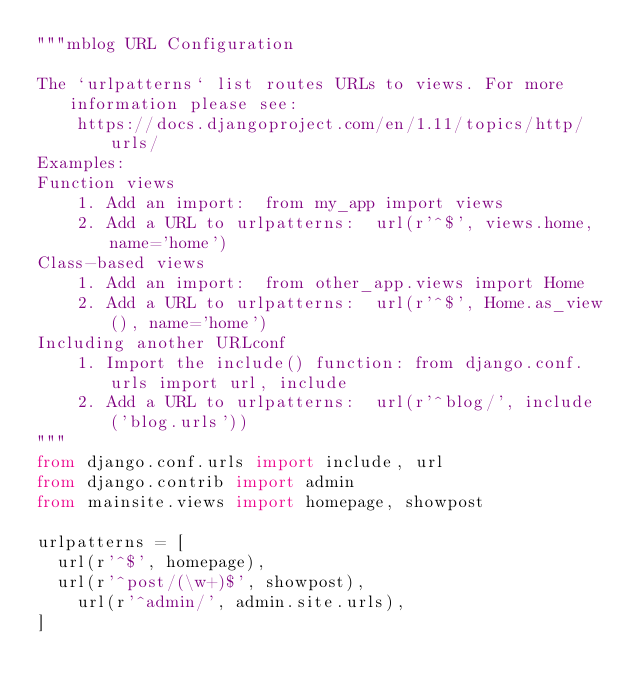<code> <loc_0><loc_0><loc_500><loc_500><_Python_>"""mblog URL Configuration

The `urlpatterns` list routes URLs to views. For more information please see:
    https://docs.djangoproject.com/en/1.11/topics/http/urls/
Examples:
Function views
    1. Add an import:  from my_app import views
    2. Add a URL to urlpatterns:  url(r'^$', views.home, name='home')
Class-based views
    1. Add an import:  from other_app.views import Home
    2. Add a URL to urlpatterns:  url(r'^$', Home.as_view(), name='home')
Including another URLconf
    1. Import the include() function: from django.conf.urls import url, include
    2. Add a URL to urlpatterns:  url(r'^blog/', include('blog.urls'))
"""
from django.conf.urls import include, url
from django.contrib import admin
from mainsite.views import homepage, showpost

urlpatterns = [
	url(r'^$', homepage),
	url(r'^post/(\w+)$', showpost),
    url(r'^admin/', admin.site.urls),
]
</code> 